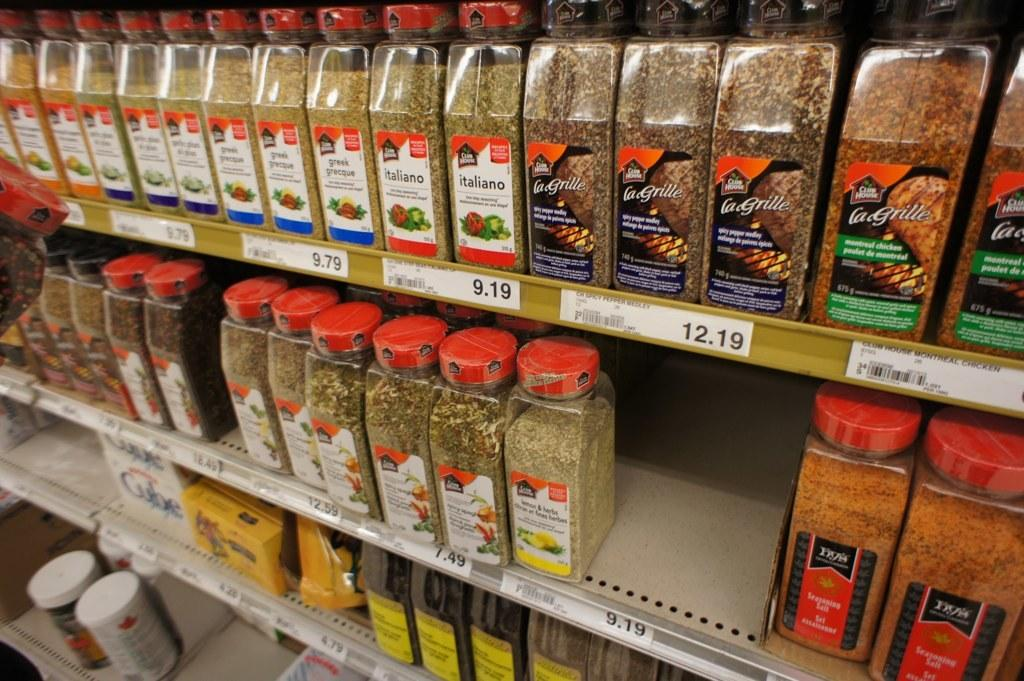<image>
Create a compact narrative representing the image presented. Several spices, including Italiano and lemon herb, are lined up on a store shelf. 